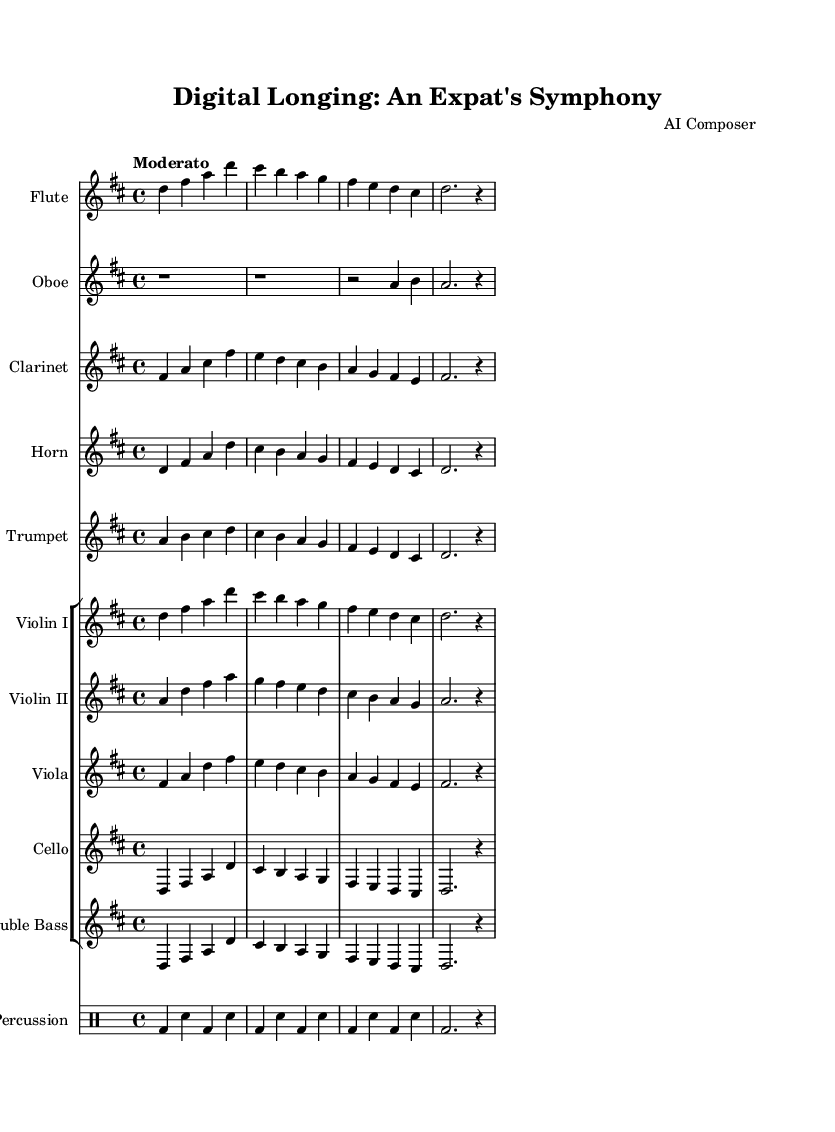What is the key signature of this music? The key signature indicated in the music is D major, which has two sharps (F# and C#).
Answer: D major What is the time signature of this music? The time signature shown in the music is 4/4, meaning there are four beats in each measure, and the quarter note gets one beat.
Answer: 4/4 What is the tempo marking of this piece? The tempo marking is "Moderato," which typically suggests a moderate speed.
Answer: Moderato How many instruments are present in this symphony? The music features a total of 10 distinct instruments: flute, oboe, clarinet, horn, trumpet, violin I, violin II, viola, cello, and double bass, plus percussion.
Answer: 10 Which instruments are in the first group of strings? The first group of strings consists of Violin I, Violin II, and Viola, which are arranged together in the score layout.
Answer: Violin I, Violin II, Viola What rhythmic pattern is predominantly used in the percussion? The percussion follows a steady pattern of bass drum and snare, alternating primarily in quarter notes, with a long half note at the end.
Answer: Bass drum and snare How many measures does the flute part contain in the excerpt? The flute part contains four measures of music, as seen by the grouped notation across the staff.
Answer: 4 